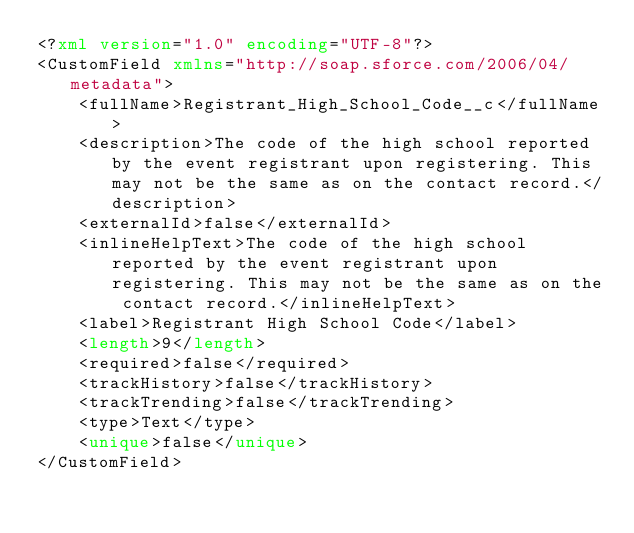Convert code to text. <code><loc_0><loc_0><loc_500><loc_500><_XML_><?xml version="1.0" encoding="UTF-8"?>
<CustomField xmlns="http://soap.sforce.com/2006/04/metadata">
    <fullName>Registrant_High_School_Code__c</fullName>
    <description>The code of the high school reported by the event registrant upon registering. This may not be the same as on the contact record.</description>
    <externalId>false</externalId>
    <inlineHelpText>The code of the high school reported by the event registrant upon registering. This may not be the same as on the contact record.</inlineHelpText>
    <label>Registrant High School Code</label>
    <length>9</length>
    <required>false</required>
    <trackHistory>false</trackHistory>
    <trackTrending>false</trackTrending>
    <type>Text</type>
    <unique>false</unique>
</CustomField>
</code> 